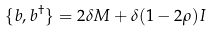<formula> <loc_0><loc_0><loc_500><loc_500>\{ b , b ^ { \dagger } \} = 2 \delta M + \delta ( 1 - 2 \rho ) I</formula> 